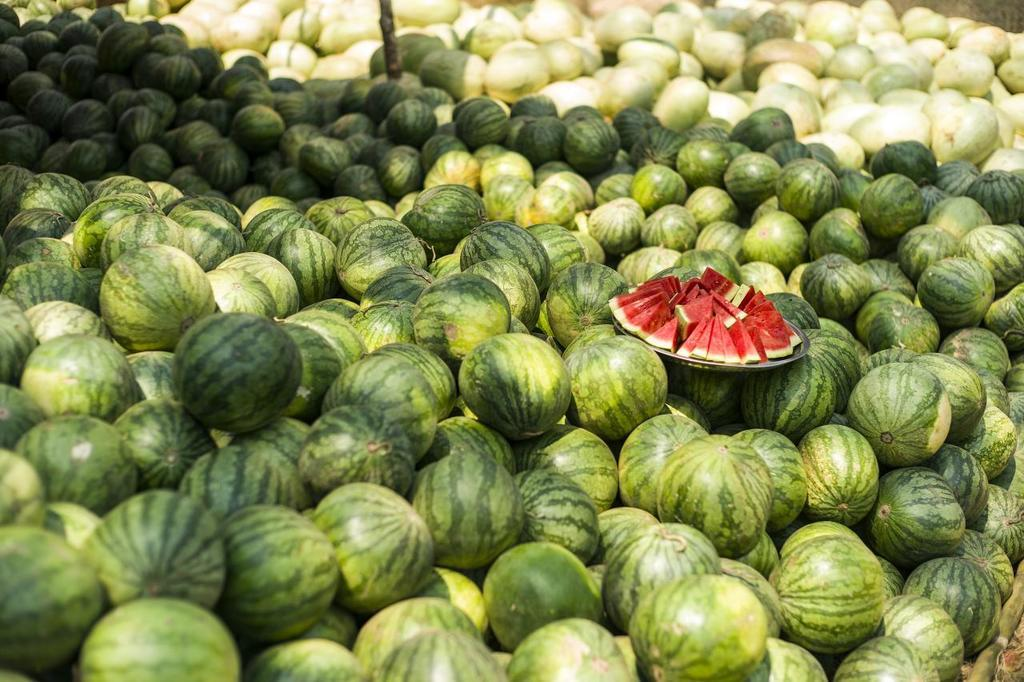What is the main subject of the image? The main subject of the image is a bulk of watermelons on the ground. Can you describe the time of day when the image was taken? The image may have been taken during the day, but the exact time is not specified. What type of setting might the image depict? The image may depict a market setting, but this is not confirmed. What type of drum can be seen in the image? There is no drum present in the image; it features a bulk of watermelons on the ground. How does the nerve system of the watermelons appear in the image? There is no mention of a nerve system in the image, as it focuses on the watermelons themselves. 